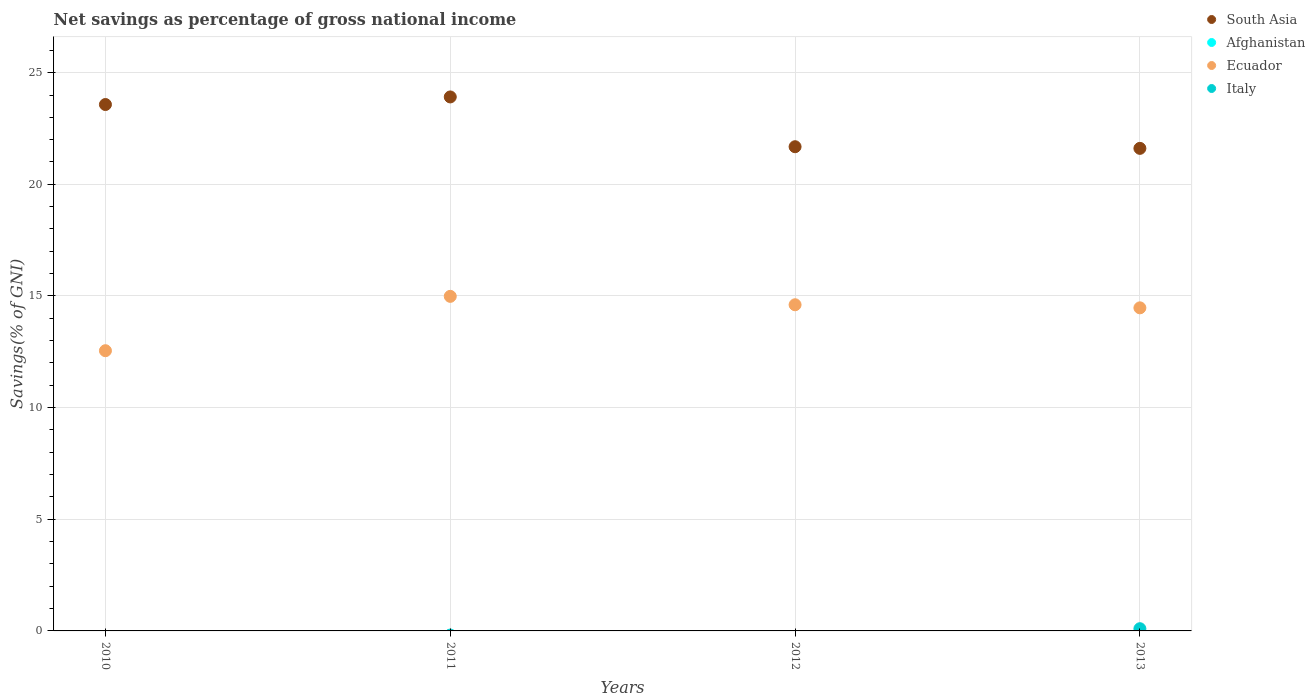What is the total savings in Afghanistan in 2012?
Provide a succinct answer. 0. Across all years, what is the maximum total savings in Ecuador?
Make the answer very short. 14.98. Across all years, what is the minimum total savings in Ecuador?
Give a very brief answer. 12.55. In which year was the total savings in Italy maximum?
Keep it short and to the point. 2013. What is the total total savings in South Asia in the graph?
Your answer should be very brief. 90.78. What is the difference between the total savings in South Asia in 2012 and that in 2013?
Provide a short and direct response. 0.07. What is the difference between the total savings in Afghanistan in 2012 and the total savings in Italy in 2010?
Your response must be concise. 0. What is the average total savings in Afghanistan per year?
Offer a terse response. 0. In the year 2013, what is the difference between the total savings in South Asia and total savings in Italy?
Provide a short and direct response. 21.51. In how many years, is the total savings in Ecuador greater than 9 %?
Give a very brief answer. 4. What is the ratio of the total savings in Ecuador in 2011 to that in 2012?
Provide a succinct answer. 1.03. What is the difference between the highest and the second highest total savings in Ecuador?
Your answer should be compact. 0.38. What is the difference between the highest and the lowest total savings in South Asia?
Ensure brevity in your answer.  2.3. Is it the case that in every year, the sum of the total savings in Afghanistan and total savings in Ecuador  is greater than the sum of total savings in South Asia and total savings in Italy?
Offer a very short reply. Yes. Is the total savings in South Asia strictly greater than the total savings in Afghanistan over the years?
Your answer should be compact. Yes. How many dotlines are there?
Your response must be concise. 3. What is the title of the graph?
Make the answer very short. Net savings as percentage of gross national income. Does "Lithuania" appear as one of the legend labels in the graph?
Ensure brevity in your answer.  No. What is the label or title of the X-axis?
Offer a terse response. Years. What is the label or title of the Y-axis?
Ensure brevity in your answer.  Savings(% of GNI). What is the Savings(% of GNI) of South Asia in 2010?
Offer a terse response. 23.57. What is the Savings(% of GNI) in Ecuador in 2010?
Provide a short and direct response. 12.55. What is the Savings(% of GNI) in Italy in 2010?
Your answer should be very brief. 0. What is the Savings(% of GNI) of South Asia in 2011?
Offer a terse response. 23.91. What is the Savings(% of GNI) in Ecuador in 2011?
Offer a very short reply. 14.98. What is the Savings(% of GNI) in South Asia in 2012?
Your answer should be compact. 21.68. What is the Savings(% of GNI) of Afghanistan in 2012?
Your response must be concise. 0. What is the Savings(% of GNI) in Ecuador in 2012?
Make the answer very short. 14.61. What is the Savings(% of GNI) of South Asia in 2013?
Keep it short and to the point. 21.61. What is the Savings(% of GNI) of Afghanistan in 2013?
Your response must be concise. 0. What is the Savings(% of GNI) of Ecuador in 2013?
Provide a succinct answer. 14.47. What is the Savings(% of GNI) in Italy in 2013?
Your answer should be very brief. 0.1. Across all years, what is the maximum Savings(% of GNI) in South Asia?
Provide a short and direct response. 23.91. Across all years, what is the maximum Savings(% of GNI) in Ecuador?
Provide a short and direct response. 14.98. Across all years, what is the maximum Savings(% of GNI) of Italy?
Make the answer very short. 0.1. Across all years, what is the minimum Savings(% of GNI) of South Asia?
Ensure brevity in your answer.  21.61. Across all years, what is the minimum Savings(% of GNI) of Ecuador?
Provide a short and direct response. 12.55. Across all years, what is the minimum Savings(% of GNI) in Italy?
Your answer should be compact. 0. What is the total Savings(% of GNI) in South Asia in the graph?
Keep it short and to the point. 90.78. What is the total Savings(% of GNI) in Ecuador in the graph?
Offer a very short reply. 56.61. What is the total Savings(% of GNI) in Italy in the graph?
Ensure brevity in your answer.  0.1. What is the difference between the Savings(% of GNI) of South Asia in 2010 and that in 2011?
Provide a short and direct response. -0.34. What is the difference between the Savings(% of GNI) in Ecuador in 2010 and that in 2011?
Ensure brevity in your answer.  -2.43. What is the difference between the Savings(% of GNI) in South Asia in 2010 and that in 2012?
Your response must be concise. 1.89. What is the difference between the Savings(% of GNI) of Ecuador in 2010 and that in 2012?
Your answer should be compact. -2.06. What is the difference between the Savings(% of GNI) of South Asia in 2010 and that in 2013?
Give a very brief answer. 1.96. What is the difference between the Savings(% of GNI) of Ecuador in 2010 and that in 2013?
Provide a succinct answer. -1.92. What is the difference between the Savings(% of GNI) in South Asia in 2011 and that in 2012?
Ensure brevity in your answer.  2.23. What is the difference between the Savings(% of GNI) in Ecuador in 2011 and that in 2012?
Offer a terse response. 0.38. What is the difference between the Savings(% of GNI) in South Asia in 2011 and that in 2013?
Offer a terse response. 2.3. What is the difference between the Savings(% of GNI) of Ecuador in 2011 and that in 2013?
Keep it short and to the point. 0.51. What is the difference between the Savings(% of GNI) in South Asia in 2012 and that in 2013?
Ensure brevity in your answer.  0.07. What is the difference between the Savings(% of GNI) of Ecuador in 2012 and that in 2013?
Provide a short and direct response. 0.14. What is the difference between the Savings(% of GNI) in South Asia in 2010 and the Savings(% of GNI) in Ecuador in 2011?
Provide a succinct answer. 8.59. What is the difference between the Savings(% of GNI) of South Asia in 2010 and the Savings(% of GNI) of Ecuador in 2012?
Offer a very short reply. 8.97. What is the difference between the Savings(% of GNI) of South Asia in 2010 and the Savings(% of GNI) of Ecuador in 2013?
Ensure brevity in your answer.  9.11. What is the difference between the Savings(% of GNI) in South Asia in 2010 and the Savings(% of GNI) in Italy in 2013?
Offer a terse response. 23.47. What is the difference between the Savings(% of GNI) of Ecuador in 2010 and the Savings(% of GNI) of Italy in 2013?
Your answer should be compact. 12.45. What is the difference between the Savings(% of GNI) in South Asia in 2011 and the Savings(% of GNI) in Ecuador in 2012?
Offer a very short reply. 9.31. What is the difference between the Savings(% of GNI) in South Asia in 2011 and the Savings(% of GNI) in Ecuador in 2013?
Provide a short and direct response. 9.44. What is the difference between the Savings(% of GNI) in South Asia in 2011 and the Savings(% of GNI) in Italy in 2013?
Offer a very short reply. 23.81. What is the difference between the Savings(% of GNI) of Ecuador in 2011 and the Savings(% of GNI) of Italy in 2013?
Provide a short and direct response. 14.88. What is the difference between the Savings(% of GNI) in South Asia in 2012 and the Savings(% of GNI) in Ecuador in 2013?
Provide a succinct answer. 7.22. What is the difference between the Savings(% of GNI) in South Asia in 2012 and the Savings(% of GNI) in Italy in 2013?
Give a very brief answer. 21.59. What is the difference between the Savings(% of GNI) of Ecuador in 2012 and the Savings(% of GNI) of Italy in 2013?
Ensure brevity in your answer.  14.51. What is the average Savings(% of GNI) in South Asia per year?
Your answer should be compact. 22.7. What is the average Savings(% of GNI) in Afghanistan per year?
Ensure brevity in your answer.  0. What is the average Savings(% of GNI) of Ecuador per year?
Make the answer very short. 14.15. What is the average Savings(% of GNI) of Italy per year?
Ensure brevity in your answer.  0.02. In the year 2010, what is the difference between the Savings(% of GNI) of South Asia and Savings(% of GNI) of Ecuador?
Provide a short and direct response. 11.03. In the year 2011, what is the difference between the Savings(% of GNI) of South Asia and Savings(% of GNI) of Ecuador?
Make the answer very short. 8.93. In the year 2012, what is the difference between the Savings(% of GNI) of South Asia and Savings(% of GNI) of Ecuador?
Your response must be concise. 7.08. In the year 2013, what is the difference between the Savings(% of GNI) of South Asia and Savings(% of GNI) of Ecuador?
Keep it short and to the point. 7.14. In the year 2013, what is the difference between the Savings(% of GNI) of South Asia and Savings(% of GNI) of Italy?
Ensure brevity in your answer.  21.51. In the year 2013, what is the difference between the Savings(% of GNI) in Ecuador and Savings(% of GNI) in Italy?
Your response must be concise. 14.37. What is the ratio of the Savings(% of GNI) of South Asia in 2010 to that in 2011?
Offer a terse response. 0.99. What is the ratio of the Savings(% of GNI) in Ecuador in 2010 to that in 2011?
Keep it short and to the point. 0.84. What is the ratio of the Savings(% of GNI) in South Asia in 2010 to that in 2012?
Make the answer very short. 1.09. What is the ratio of the Savings(% of GNI) in Ecuador in 2010 to that in 2012?
Ensure brevity in your answer.  0.86. What is the ratio of the Savings(% of GNI) in South Asia in 2010 to that in 2013?
Your response must be concise. 1.09. What is the ratio of the Savings(% of GNI) in Ecuador in 2010 to that in 2013?
Offer a very short reply. 0.87. What is the ratio of the Savings(% of GNI) in South Asia in 2011 to that in 2012?
Ensure brevity in your answer.  1.1. What is the ratio of the Savings(% of GNI) in Ecuador in 2011 to that in 2012?
Your answer should be compact. 1.03. What is the ratio of the Savings(% of GNI) of South Asia in 2011 to that in 2013?
Offer a terse response. 1.11. What is the ratio of the Savings(% of GNI) of Ecuador in 2011 to that in 2013?
Provide a short and direct response. 1.04. What is the ratio of the Savings(% of GNI) in South Asia in 2012 to that in 2013?
Give a very brief answer. 1. What is the ratio of the Savings(% of GNI) of Ecuador in 2012 to that in 2013?
Provide a succinct answer. 1.01. What is the difference between the highest and the second highest Savings(% of GNI) in South Asia?
Give a very brief answer. 0.34. What is the difference between the highest and the second highest Savings(% of GNI) of Ecuador?
Your answer should be compact. 0.38. What is the difference between the highest and the lowest Savings(% of GNI) of South Asia?
Keep it short and to the point. 2.3. What is the difference between the highest and the lowest Savings(% of GNI) in Ecuador?
Offer a terse response. 2.43. What is the difference between the highest and the lowest Savings(% of GNI) of Italy?
Keep it short and to the point. 0.1. 